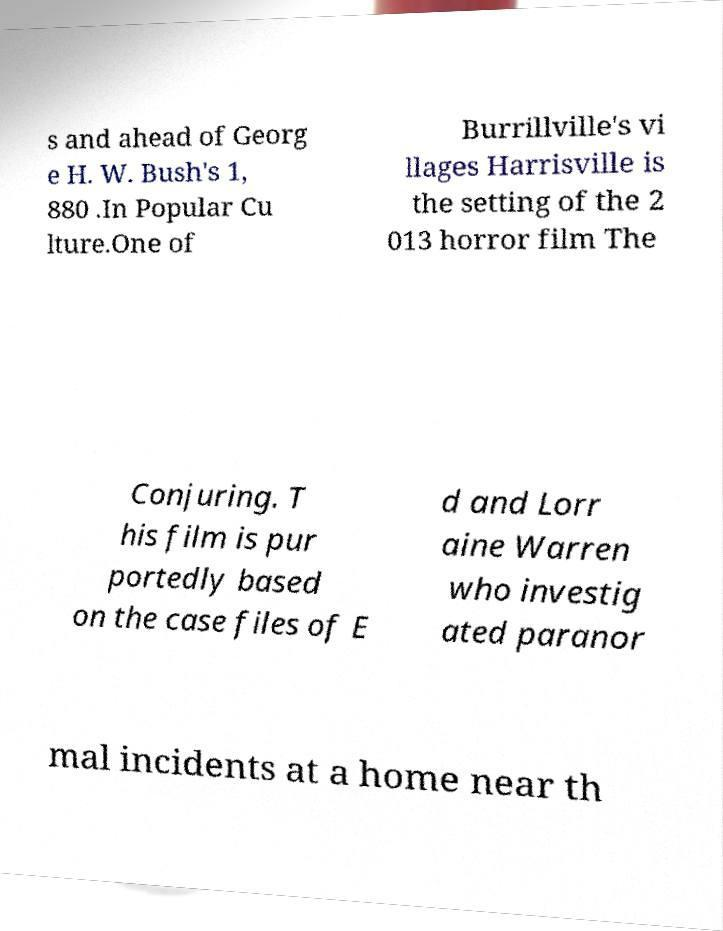Please identify and transcribe the text found in this image. s and ahead of Georg e H. W. Bush's 1, 880 .In Popular Cu lture.One of Burrillville's vi llages Harrisville is the setting of the 2 013 horror film The Conjuring. T his film is pur portedly based on the case files of E d and Lorr aine Warren who investig ated paranor mal incidents at a home near th 